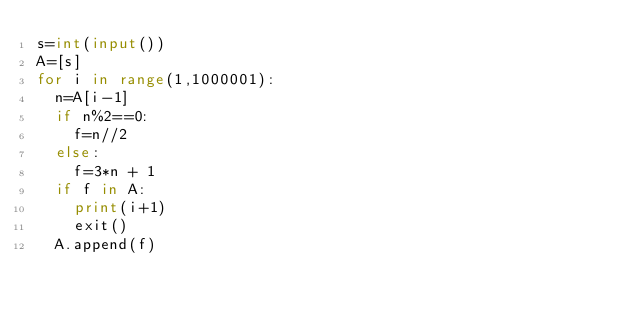Convert code to text. <code><loc_0><loc_0><loc_500><loc_500><_Python_>s=int(input())
A=[s]
for i in range(1,1000001):
  n=A[i-1]
  if n%2==0:
    f=n//2
  else:
    f=3*n + 1
  if f in A:
    print(i+1)
    exit()
  A.append(f)</code> 